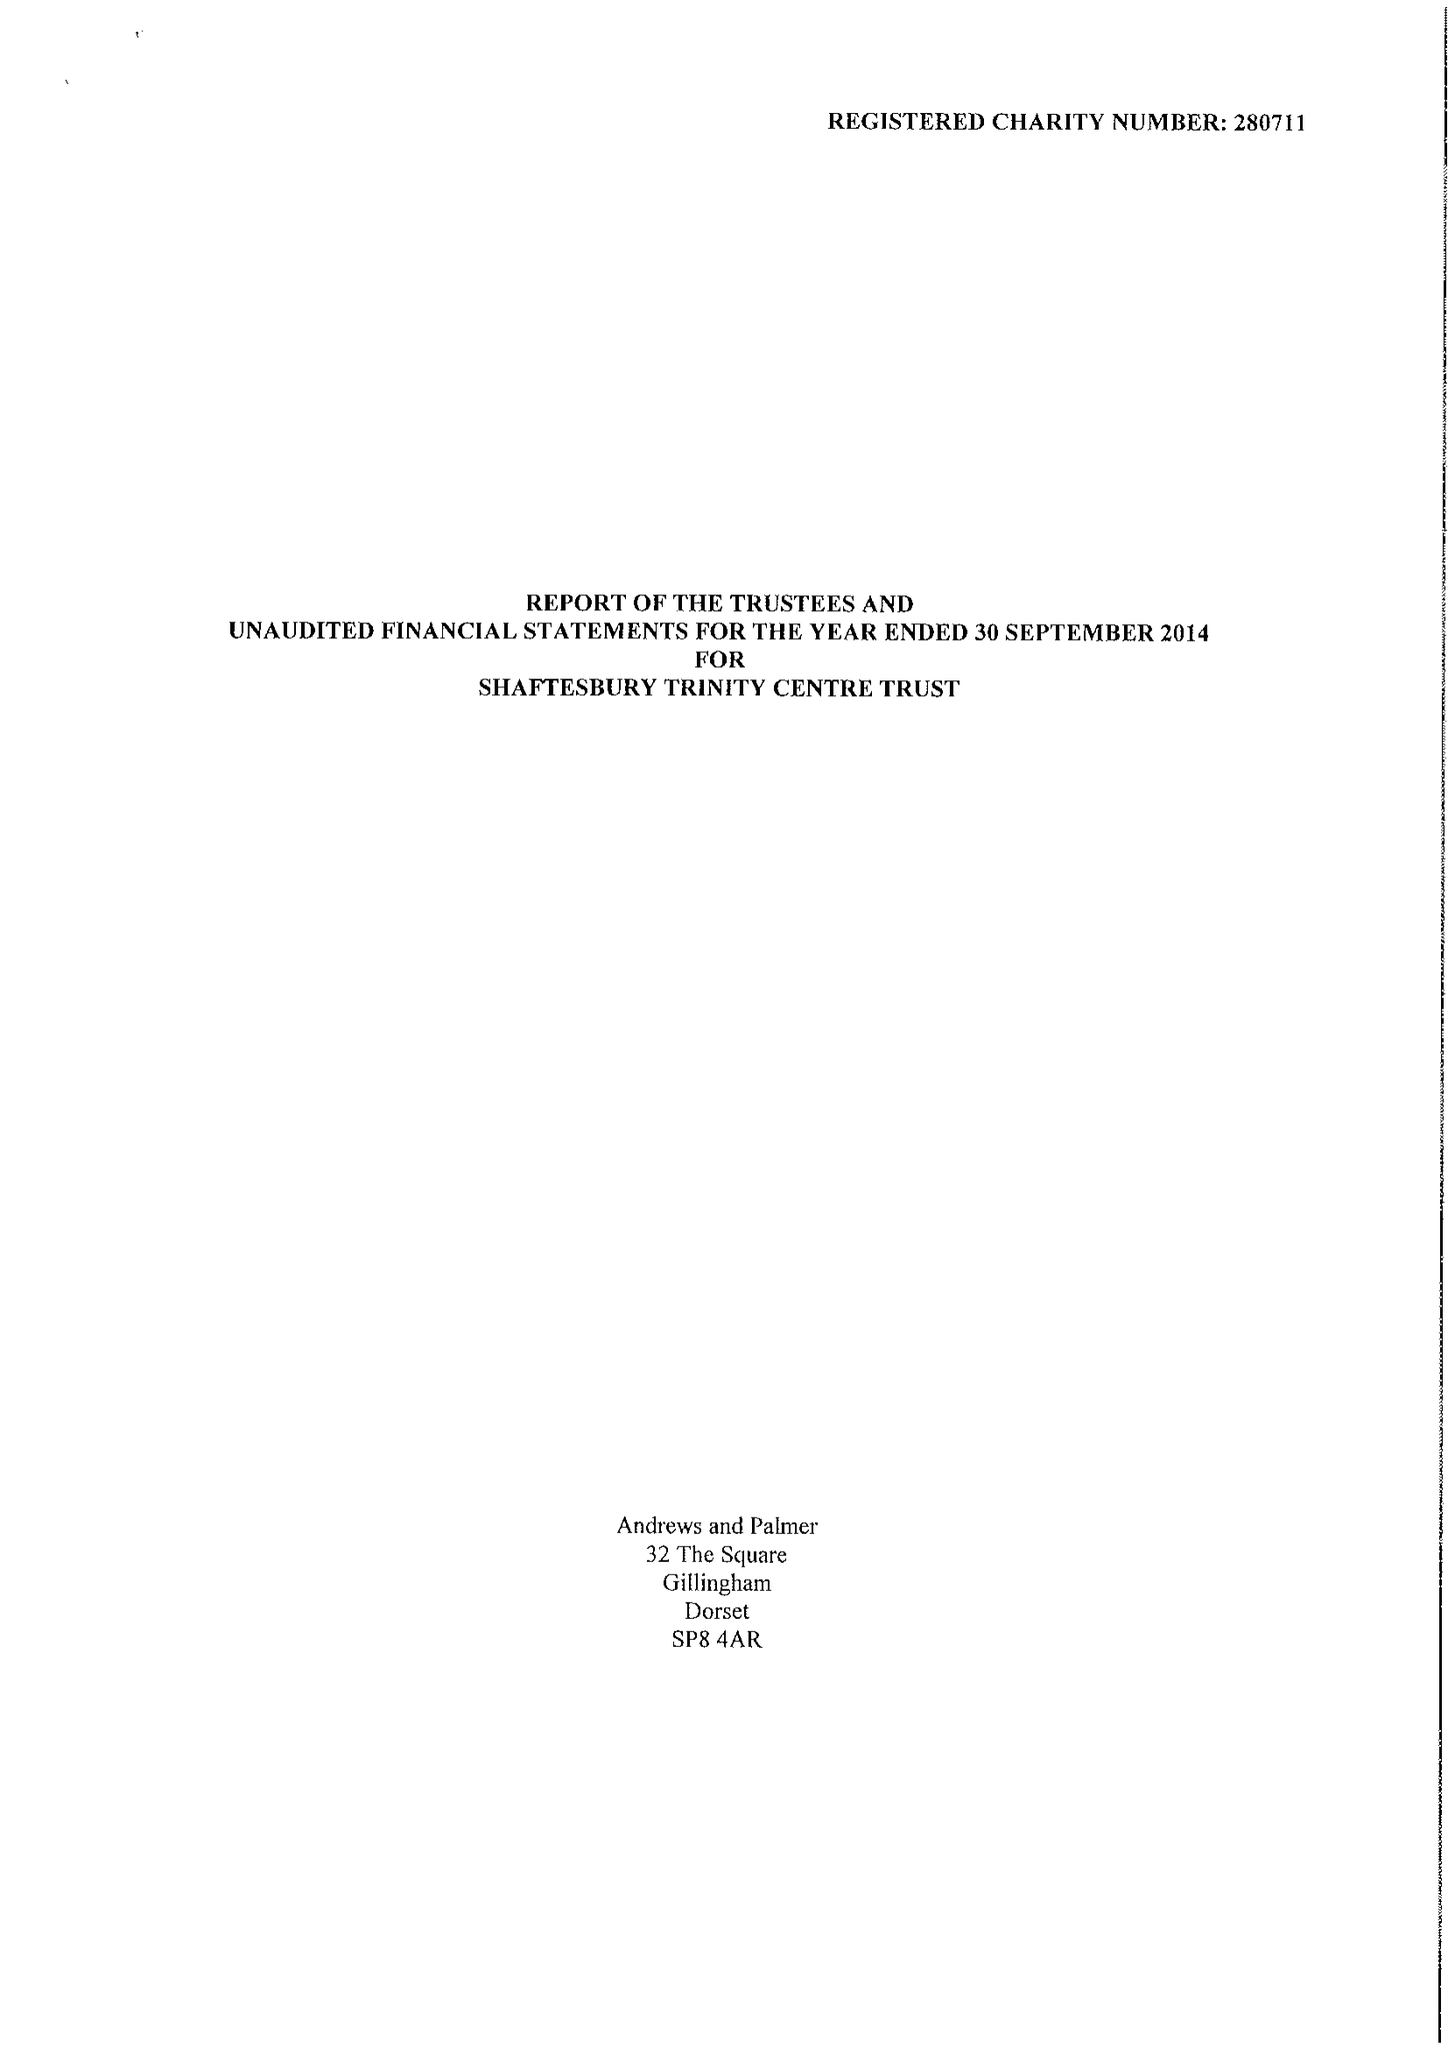What is the value for the report_date?
Answer the question using a single word or phrase. 2014-09-30 